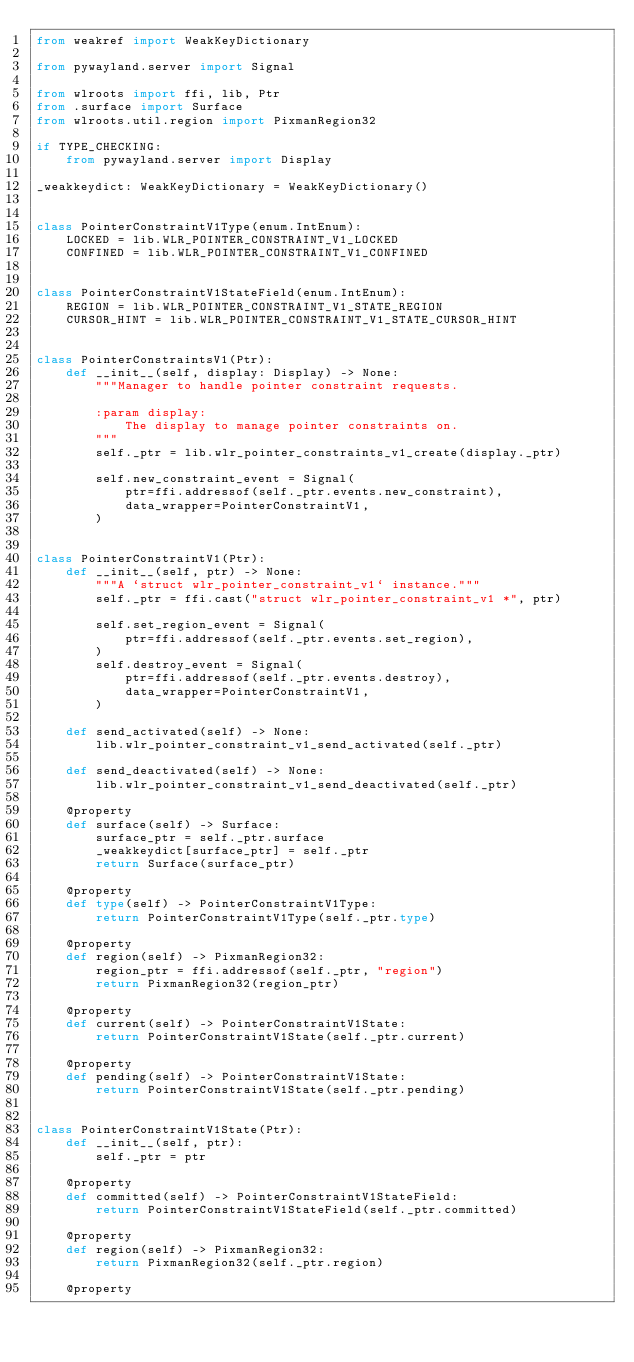<code> <loc_0><loc_0><loc_500><loc_500><_Python_>from weakref import WeakKeyDictionary

from pywayland.server import Signal

from wlroots import ffi, lib, Ptr
from .surface import Surface
from wlroots.util.region import PixmanRegion32

if TYPE_CHECKING:
    from pywayland.server import Display

_weakkeydict: WeakKeyDictionary = WeakKeyDictionary()


class PointerConstraintV1Type(enum.IntEnum):
    LOCKED = lib.WLR_POINTER_CONSTRAINT_V1_LOCKED
    CONFINED = lib.WLR_POINTER_CONSTRAINT_V1_CONFINED


class PointerConstraintV1StateField(enum.IntEnum):
    REGION = lib.WLR_POINTER_CONSTRAINT_V1_STATE_REGION
    CURSOR_HINT = lib.WLR_POINTER_CONSTRAINT_V1_STATE_CURSOR_HINT


class PointerConstraintsV1(Ptr):
    def __init__(self, display: Display) -> None:
        """Manager to handle pointer constraint requests.

        :param display:
            The display to manage pointer constraints on.
        """
        self._ptr = lib.wlr_pointer_constraints_v1_create(display._ptr)

        self.new_constraint_event = Signal(
            ptr=ffi.addressof(self._ptr.events.new_constraint),
            data_wrapper=PointerConstraintV1,
        )


class PointerConstraintV1(Ptr):
    def __init__(self, ptr) -> None:
        """A `struct wlr_pointer_constraint_v1` instance."""
        self._ptr = ffi.cast("struct wlr_pointer_constraint_v1 *", ptr)

        self.set_region_event = Signal(
            ptr=ffi.addressof(self._ptr.events.set_region),
        )
        self.destroy_event = Signal(
            ptr=ffi.addressof(self._ptr.events.destroy),
            data_wrapper=PointerConstraintV1,
        )

    def send_activated(self) -> None:
        lib.wlr_pointer_constraint_v1_send_activated(self._ptr)

    def send_deactivated(self) -> None:
        lib.wlr_pointer_constraint_v1_send_deactivated(self._ptr)

    @property
    def surface(self) -> Surface:
        surface_ptr = self._ptr.surface
        _weakkeydict[surface_ptr] = self._ptr
        return Surface(surface_ptr)

    @property
    def type(self) -> PointerConstraintV1Type:
        return PointerConstraintV1Type(self._ptr.type)

    @property
    def region(self) -> PixmanRegion32:
        region_ptr = ffi.addressof(self._ptr, "region")
        return PixmanRegion32(region_ptr)

    @property
    def current(self) -> PointerConstraintV1State:
        return PointerConstraintV1State(self._ptr.current)

    @property
    def pending(self) -> PointerConstraintV1State:
        return PointerConstraintV1State(self._ptr.pending)


class PointerConstraintV1State(Ptr):
    def __init__(self, ptr):
        self._ptr = ptr

    @property
    def committed(self) -> PointerConstraintV1StateField:
        return PointerConstraintV1StateField(self._ptr.committed)

    @property
    def region(self) -> PixmanRegion32:
        return PixmanRegion32(self._ptr.region)

    @property</code> 